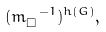<formula> <loc_0><loc_0><loc_500><loc_500>( m _ { \square } ^ { \ - 1 } ) ^ { h ( G ) } ,</formula> 